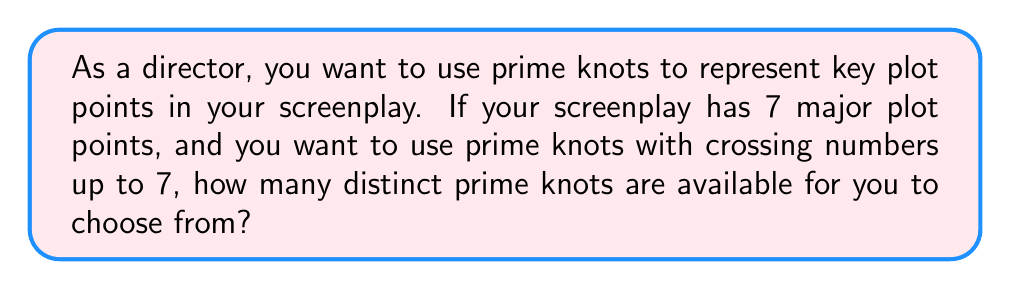What is the answer to this math problem? To solve this problem, we need to follow these steps:

1. Understand what prime knots are:
   Prime knots are knots that cannot be decomposed into simpler knots.

2. Recall the number of prime knots for each crossing number up to 7:
   - Crossing number 3: 1 prime knot (trefoil knot)
   - Crossing number 4: 1 prime knot (figure-eight knot)
   - Crossing number 5: 2 prime knots
   - Crossing number 6: 3 prime knots
   - Crossing number 7: 7 prime knots

3. Sum up the number of prime knots:
   $$1 + 1 + 2 + 3 + 7 = 14$$

Therefore, there are 14 distinct prime knots with crossing numbers up to 7 that can be used to represent the key plot points in the screenplay.

Note: This selection provides enough variety for the 7 major plot points, allowing the director to choose knots that best represent the complexity or significance of each plot point.
Answer: 14 prime knots 